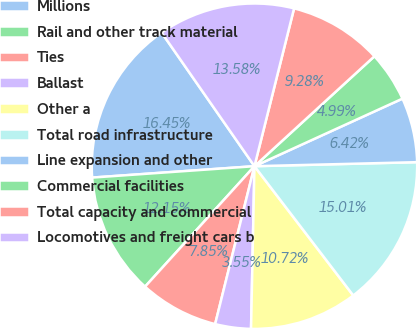<chart> <loc_0><loc_0><loc_500><loc_500><pie_chart><fcel>Millions<fcel>Rail and other track material<fcel>Ties<fcel>Ballast<fcel>Other a<fcel>Total road infrastructure<fcel>Line expansion and other<fcel>Commercial facilities<fcel>Total capacity and commercial<fcel>Locomotives and freight cars b<nl><fcel>16.45%<fcel>12.15%<fcel>7.85%<fcel>3.55%<fcel>10.72%<fcel>15.01%<fcel>6.42%<fcel>4.99%<fcel>9.28%<fcel>13.58%<nl></chart> 